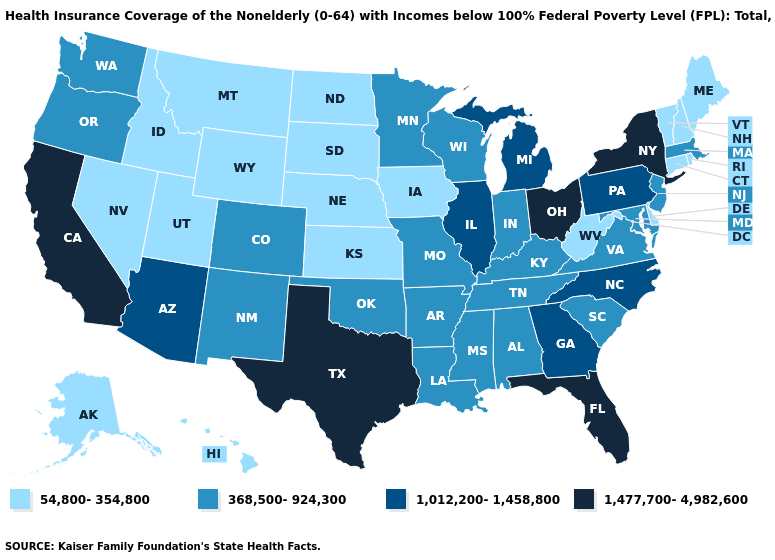What is the value of Iowa?
Be succinct. 54,800-354,800. How many symbols are there in the legend?
Write a very short answer. 4. Does Delaware have the lowest value in the South?
Keep it brief. Yes. Among the states that border Texas , which have the lowest value?
Concise answer only. Arkansas, Louisiana, New Mexico, Oklahoma. Among the states that border Mississippi , which have the lowest value?
Quick response, please. Alabama, Arkansas, Louisiana, Tennessee. What is the value of Nevada?
Write a very short answer. 54,800-354,800. How many symbols are there in the legend?
Keep it brief. 4. Does Colorado have a higher value than Wyoming?
Write a very short answer. Yes. Among the states that border Illinois , does Missouri have the lowest value?
Short answer required. No. Name the states that have a value in the range 368,500-924,300?
Give a very brief answer. Alabama, Arkansas, Colorado, Indiana, Kentucky, Louisiana, Maryland, Massachusetts, Minnesota, Mississippi, Missouri, New Jersey, New Mexico, Oklahoma, Oregon, South Carolina, Tennessee, Virginia, Washington, Wisconsin. Does Georgia have the highest value in the South?
Write a very short answer. No. Which states have the lowest value in the USA?
Answer briefly. Alaska, Connecticut, Delaware, Hawaii, Idaho, Iowa, Kansas, Maine, Montana, Nebraska, Nevada, New Hampshire, North Dakota, Rhode Island, South Dakota, Utah, Vermont, West Virginia, Wyoming. Which states have the lowest value in the Northeast?
Answer briefly. Connecticut, Maine, New Hampshire, Rhode Island, Vermont. Name the states that have a value in the range 368,500-924,300?
Quick response, please. Alabama, Arkansas, Colorado, Indiana, Kentucky, Louisiana, Maryland, Massachusetts, Minnesota, Mississippi, Missouri, New Jersey, New Mexico, Oklahoma, Oregon, South Carolina, Tennessee, Virginia, Washington, Wisconsin. What is the value of Minnesota?
Write a very short answer. 368,500-924,300. 